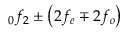Convert formula to latex. <formula><loc_0><loc_0><loc_500><loc_500>_ { 0 } f _ { 2 } \pm \left ( 2 f _ { e } \mp 2 f _ { o } \right )</formula> 